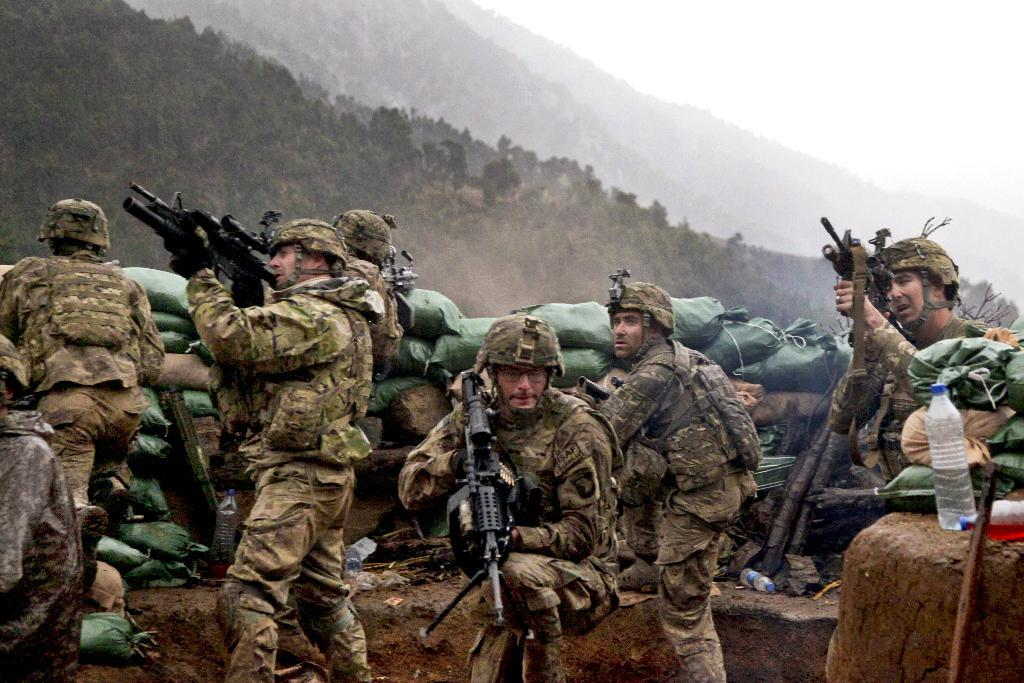How many people are in the image? There is a group of people in the image, but the exact number is not specified. What are the people holding in the image? The people are holding guns in the image. What other objects can be seen in the image besides guns? There are bottles and bags visible in the image. What type of natural environment is present in the image? There are trees and mountains in the image, indicating a natural setting. What is visible in the background of the image? The sky is visible in the background of the image. What type of fruit is hanging from the trees in the image? There is no fruit visible in the image; only trees and mountains are present. What shape is the trail that the people are walking on in the image? There is no trail visible in the image; the people are not shown walking. 